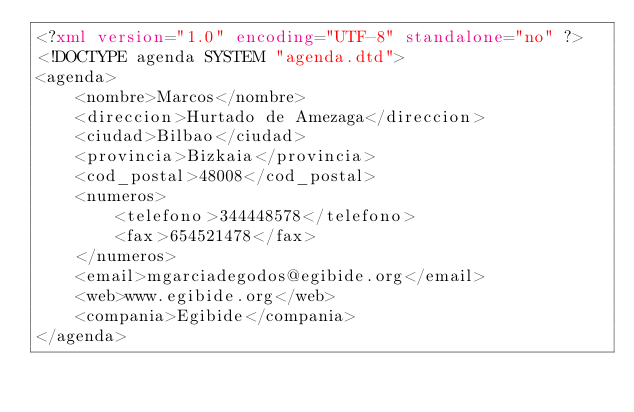Convert code to text. <code><loc_0><loc_0><loc_500><loc_500><_XML_><?xml version="1.0" encoding="UTF-8" standalone="no" ?>
<!DOCTYPE agenda SYSTEM "agenda.dtd">
<agenda>
    <nombre>Marcos</nombre>
    <direccion>Hurtado de Amezaga</direccion>
    <ciudad>Bilbao</ciudad>
    <provincia>Bizkaia</provincia>
    <cod_postal>48008</cod_postal>
    <numeros>
        <telefono>344448578</telefono>
        <fax>654521478</fax>
    </numeros>
    <email>mgarciadegodos@egibide.org</email>
    <web>www.egibide.org</web>
    <compania>Egibide</compania>
</agenda></code> 